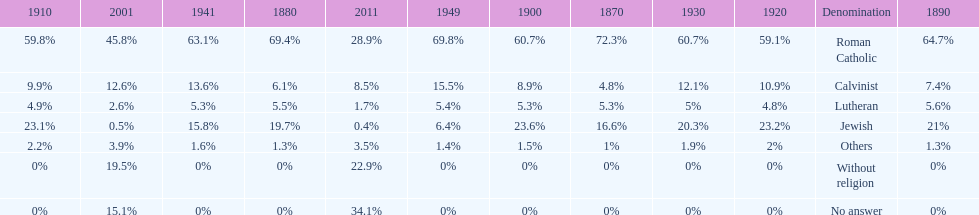The percentage of people who identified as calvinist was, at most, how much? 15.5%. 